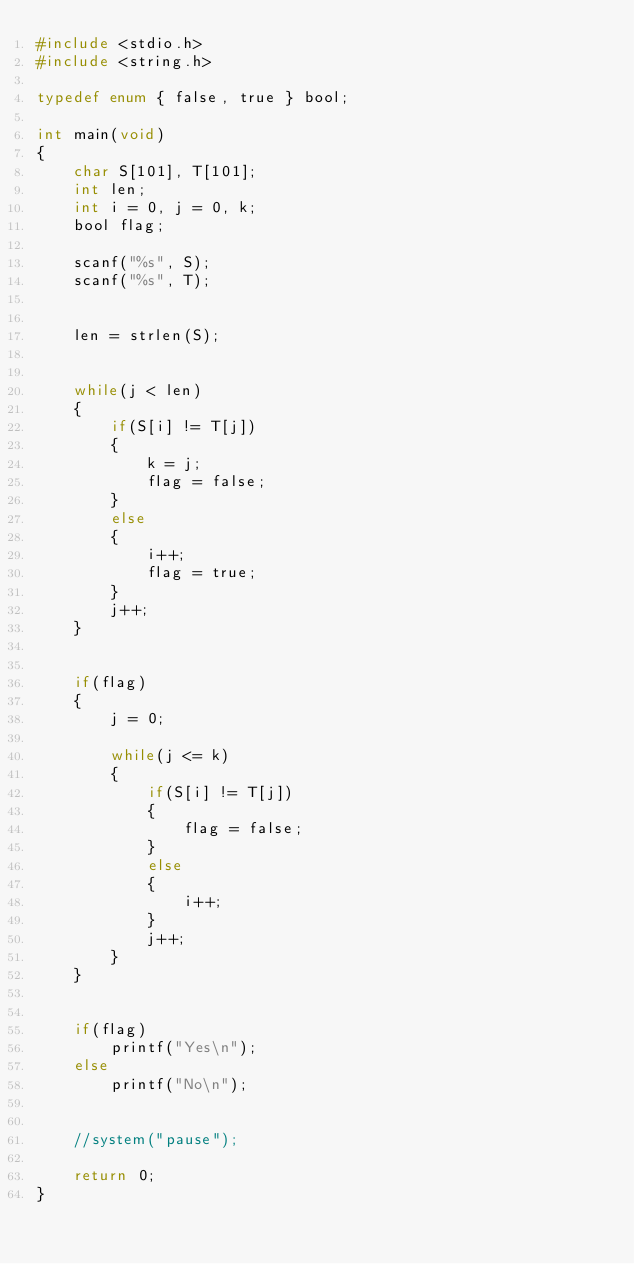<code> <loc_0><loc_0><loc_500><loc_500><_C_>#include <stdio.h>
#include <string.h>

typedef enum { false, true } bool;

int main(void)
{
    char S[101], T[101];
    int len;
    int i = 0, j = 0, k;
    bool flag;
    
    scanf("%s", S);
    scanf("%s", T);
    
    
    len = strlen(S);
    
    
    while(j < len)
    {
        if(S[i] != T[j])
        {
            k = j;
            flag = false;
        }
        else
        {
            i++;
            flag = true;
        }
        j++;
    }
    
    
    if(flag)
    {
        j = 0;
        
        while(j <= k)
        {
            if(S[i] != T[j])
            {
                flag = false;
            }
            else
            {
                i++;
            }
            j++;
        }
    }
    
    
    if(flag)
        printf("Yes\n");
    else
        printf("No\n");
        

    //system("pause");
    
    return 0;
}</code> 